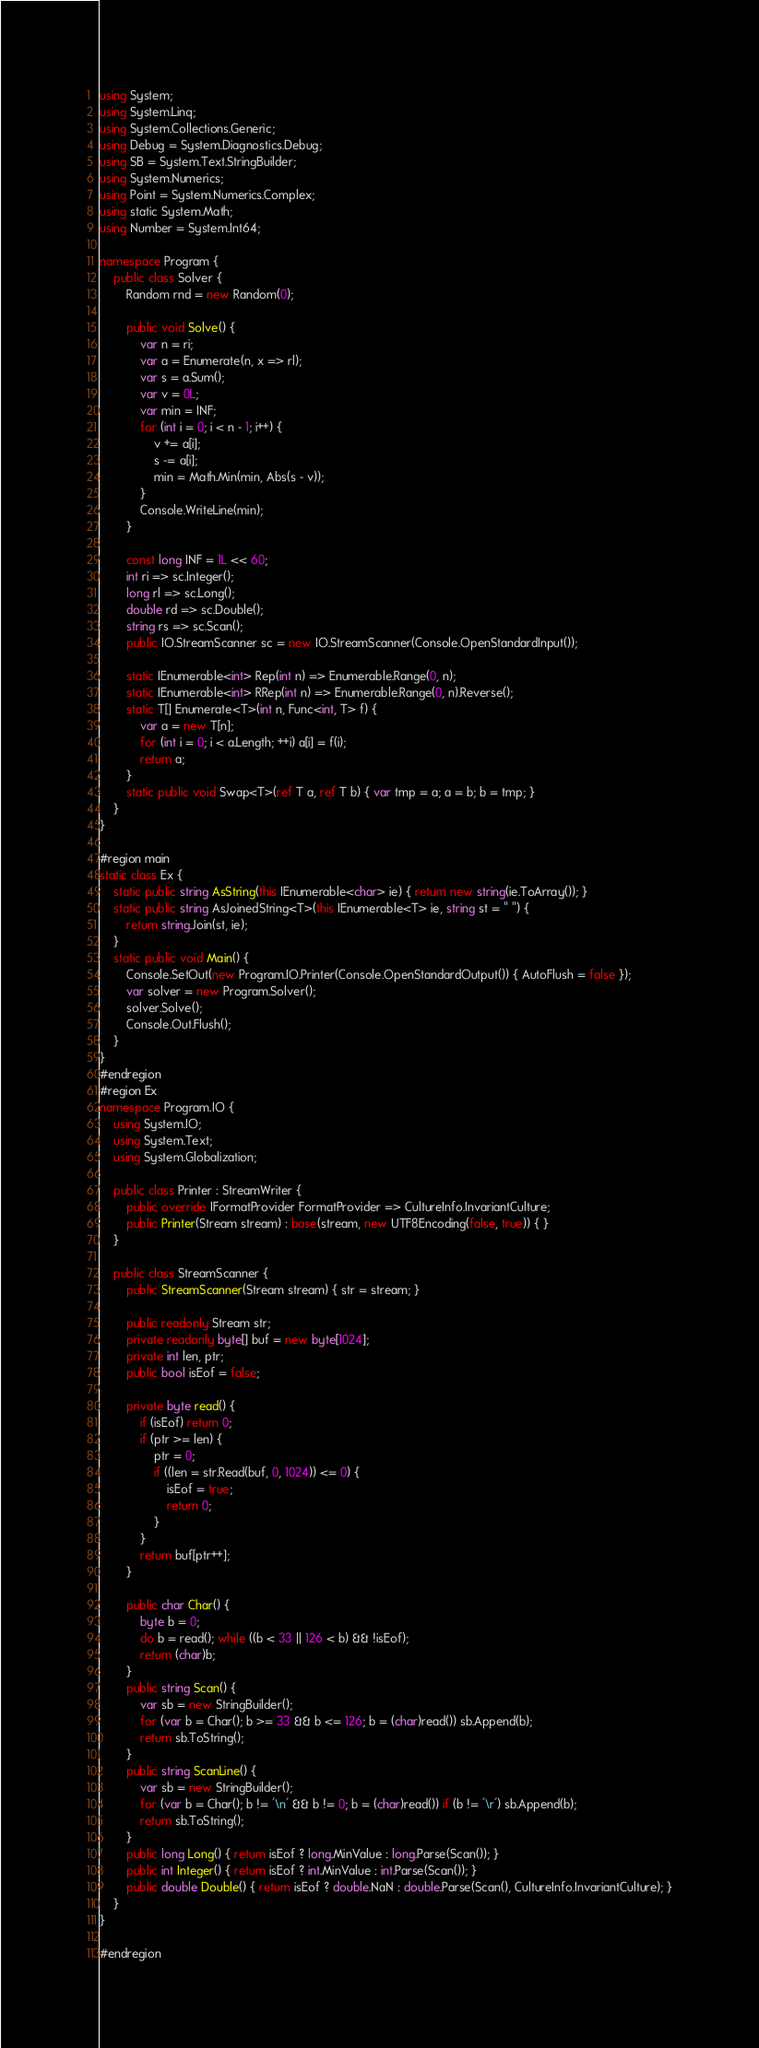Convert code to text. <code><loc_0><loc_0><loc_500><loc_500><_C#_>using System;
using System.Linq;
using System.Collections.Generic;
using Debug = System.Diagnostics.Debug;
using SB = System.Text.StringBuilder;
using System.Numerics;
using Point = System.Numerics.Complex;
using static System.Math;
using Number = System.Int64;

namespace Program {
    public class Solver {
        Random rnd = new Random(0);

        public void Solve() {
            var n = ri;
            var a = Enumerate(n, x => rl);
            var s = a.Sum();
            var v = 0L;
            var min = INF;
            for (int i = 0; i < n - 1; i++) {
                v += a[i];
                s -= a[i];
                min = Math.Min(min, Abs(s - v));
            }
            Console.WriteLine(min);
        }

        const long INF = 1L << 60;
        int ri => sc.Integer();
        long rl => sc.Long();
        double rd => sc.Double();
        string rs => sc.Scan();
        public IO.StreamScanner sc = new IO.StreamScanner(Console.OpenStandardInput());

        static IEnumerable<int> Rep(int n) => Enumerable.Range(0, n);
        static IEnumerable<int> RRep(int n) => Enumerable.Range(0, n).Reverse();
        static T[] Enumerate<T>(int n, Func<int, T> f) {
            var a = new T[n];
            for (int i = 0; i < a.Length; ++i) a[i] = f(i);
            return a;
        }
        static public void Swap<T>(ref T a, ref T b) { var tmp = a; a = b; b = tmp; }
    }
}

#region main
static class Ex {
    static public string AsString(this IEnumerable<char> ie) { return new string(ie.ToArray()); }
    static public string AsJoinedString<T>(this IEnumerable<T> ie, string st = " ") {
        return string.Join(st, ie);
    }
    static public void Main() {
        Console.SetOut(new Program.IO.Printer(Console.OpenStandardOutput()) { AutoFlush = false });
        var solver = new Program.Solver();
        solver.Solve();
        Console.Out.Flush();
    }
}
#endregion
#region Ex
namespace Program.IO {
    using System.IO;
    using System.Text;
    using System.Globalization;

    public class Printer : StreamWriter {
        public override IFormatProvider FormatProvider => CultureInfo.InvariantCulture;
        public Printer(Stream stream) : base(stream, new UTF8Encoding(false, true)) { }
    }

    public class StreamScanner {
        public StreamScanner(Stream stream) { str = stream; }

        public readonly Stream str;
        private readonly byte[] buf = new byte[1024];
        private int len, ptr;
        public bool isEof = false;

        private byte read() {
            if (isEof) return 0;
            if (ptr >= len) {
                ptr = 0;
                if ((len = str.Read(buf, 0, 1024)) <= 0) {
                    isEof = true;
                    return 0;
                }
            }
            return buf[ptr++];
        }

        public char Char() {
            byte b = 0;
            do b = read(); while ((b < 33 || 126 < b) && !isEof);
            return (char)b;
        }
        public string Scan() {
            var sb = new StringBuilder();
            for (var b = Char(); b >= 33 && b <= 126; b = (char)read()) sb.Append(b);
            return sb.ToString();
        }
        public string ScanLine() {
            var sb = new StringBuilder();
            for (var b = Char(); b != '\n' && b != 0; b = (char)read()) if (b != '\r') sb.Append(b);
            return sb.ToString();
        }
        public long Long() { return isEof ? long.MinValue : long.Parse(Scan()); }
        public int Integer() { return isEof ? int.MinValue : int.Parse(Scan()); }
        public double Double() { return isEof ? double.NaN : double.Parse(Scan(), CultureInfo.InvariantCulture); }
    }
}

#endregion</code> 